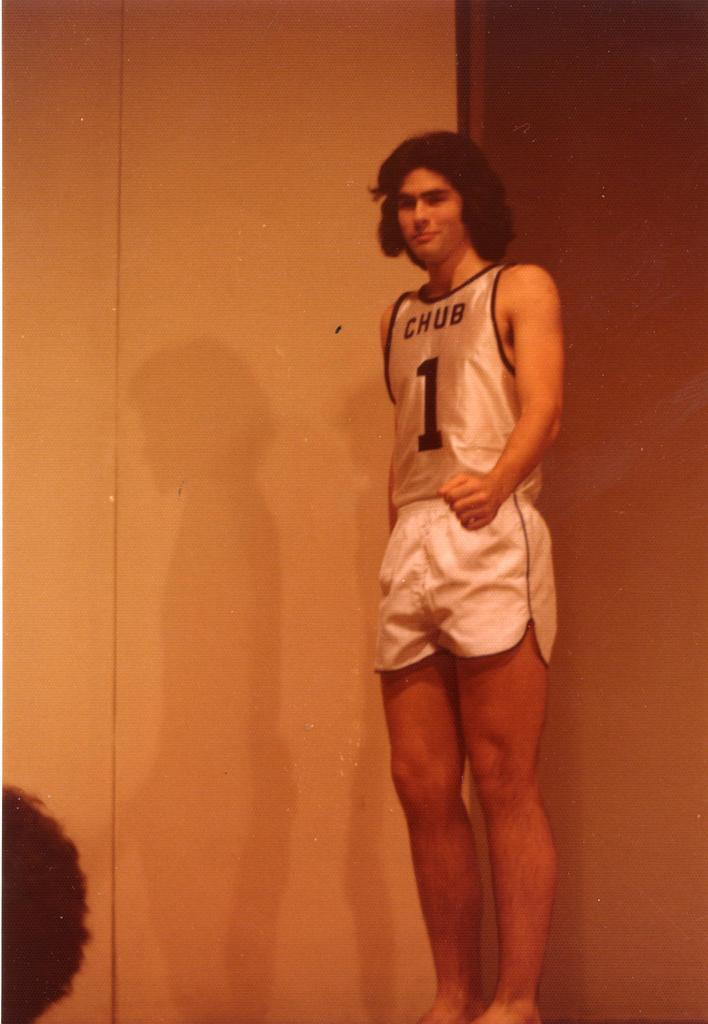Provide a one-sentence caption for the provided image. A man in a number 1 Chub jersey. 